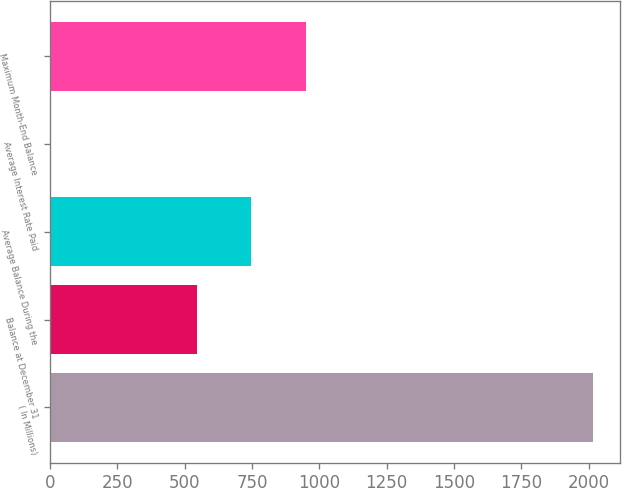Convert chart to OTSL. <chart><loc_0><loc_0><loc_500><loc_500><bar_chart><fcel>( In Millions)<fcel>Balance at December 31<fcel>Average Balance During the<fcel>Average Interest Rate Paid<fcel>Maximum Month-End Balance<nl><fcel>2015<fcel>546.6<fcel>748.1<fcel>0.05<fcel>949.6<nl></chart> 